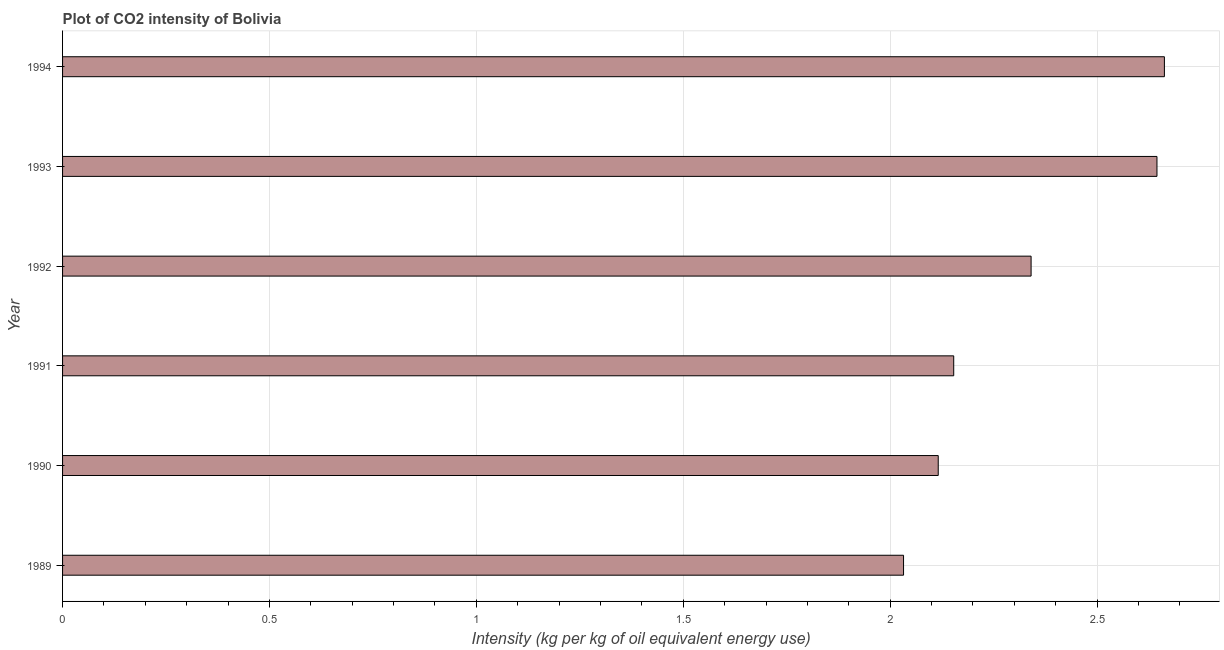Does the graph contain any zero values?
Ensure brevity in your answer.  No. Does the graph contain grids?
Provide a succinct answer. Yes. What is the title of the graph?
Offer a very short reply. Plot of CO2 intensity of Bolivia. What is the label or title of the X-axis?
Offer a terse response. Intensity (kg per kg of oil equivalent energy use). What is the co2 intensity in 1990?
Your answer should be very brief. 2.12. Across all years, what is the maximum co2 intensity?
Provide a short and direct response. 2.66. Across all years, what is the minimum co2 intensity?
Your answer should be very brief. 2.03. In which year was the co2 intensity maximum?
Give a very brief answer. 1994. In which year was the co2 intensity minimum?
Your answer should be very brief. 1989. What is the sum of the co2 intensity?
Your answer should be very brief. 13.95. What is the difference between the co2 intensity in 1989 and 1992?
Offer a terse response. -0.31. What is the average co2 intensity per year?
Offer a terse response. 2.33. What is the median co2 intensity?
Provide a succinct answer. 2.25. What is the ratio of the co2 intensity in 1992 to that in 1993?
Provide a short and direct response. 0.89. Is the co2 intensity in 1991 less than that in 1994?
Provide a succinct answer. Yes. What is the difference between the highest and the second highest co2 intensity?
Offer a very short reply. 0.02. Is the sum of the co2 intensity in 1993 and 1994 greater than the maximum co2 intensity across all years?
Your answer should be very brief. Yes. What is the difference between the highest and the lowest co2 intensity?
Provide a short and direct response. 0.63. How many years are there in the graph?
Your response must be concise. 6. What is the difference between two consecutive major ticks on the X-axis?
Your response must be concise. 0.5. Are the values on the major ticks of X-axis written in scientific E-notation?
Provide a short and direct response. No. What is the Intensity (kg per kg of oil equivalent energy use) in 1989?
Make the answer very short. 2.03. What is the Intensity (kg per kg of oil equivalent energy use) of 1990?
Keep it short and to the point. 2.12. What is the Intensity (kg per kg of oil equivalent energy use) in 1991?
Give a very brief answer. 2.15. What is the Intensity (kg per kg of oil equivalent energy use) in 1992?
Provide a short and direct response. 2.34. What is the Intensity (kg per kg of oil equivalent energy use) of 1993?
Provide a short and direct response. 2.64. What is the Intensity (kg per kg of oil equivalent energy use) of 1994?
Provide a succinct answer. 2.66. What is the difference between the Intensity (kg per kg of oil equivalent energy use) in 1989 and 1990?
Provide a short and direct response. -0.08. What is the difference between the Intensity (kg per kg of oil equivalent energy use) in 1989 and 1991?
Provide a succinct answer. -0.12. What is the difference between the Intensity (kg per kg of oil equivalent energy use) in 1989 and 1992?
Make the answer very short. -0.31. What is the difference between the Intensity (kg per kg of oil equivalent energy use) in 1989 and 1993?
Ensure brevity in your answer.  -0.61. What is the difference between the Intensity (kg per kg of oil equivalent energy use) in 1989 and 1994?
Your response must be concise. -0.63. What is the difference between the Intensity (kg per kg of oil equivalent energy use) in 1990 and 1991?
Give a very brief answer. -0.04. What is the difference between the Intensity (kg per kg of oil equivalent energy use) in 1990 and 1992?
Your response must be concise. -0.22. What is the difference between the Intensity (kg per kg of oil equivalent energy use) in 1990 and 1993?
Offer a terse response. -0.53. What is the difference between the Intensity (kg per kg of oil equivalent energy use) in 1990 and 1994?
Ensure brevity in your answer.  -0.55. What is the difference between the Intensity (kg per kg of oil equivalent energy use) in 1991 and 1992?
Provide a succinct answer. -0.19. What is the difference between the Intensity (kg per kg of oil equivalent energy use) in 1991 and 1993?
Make the answer very short. -0.49. What is the difference between the Intensity (kg per kg of oil equivalent energy use) in 1991 and 1994?
Offer a very short reply. -0.51. What is the difference between the Intensity (kg per kg of oil equivalent energy use) in 1992 and 1993?
Keep it short and to the point. -0.3. What is the difference between the Intensity (kg per kg of oil equivalent energy use) in 1992 and 1994?
Ensure brevity in your answer.  -0.32. What is the difference between the Intensity (kg per kg of oil equivalent energy use) in 1993 and 1994?
Provide a short and direct response. -0.02. What is the ratio of the Intensity (kg per kg of oil equivalent energy use) in 1989 to that in 1991?
Offer a very short reply. 0.94. What is the ratio of the Intensity (kg per kg of oil equivalent energy use) in 1989 to that in 1992?
Your response must be concise. 0.87. What is the ratio of the Intensity (kg per kg of oil equivalent energy use) in 1989 to that in 1993?
Offer a terse response. 0.77. What is the ratio of the Intensity (kg per kg of oil equivalent energy use) in 1989 to that in 1994?
Give a very brief answer. 0.76. What is the ratio of the Intensity (kg per kg of oil equivalent energy use) in 1990 to that in 1992?
Give a very brief answer. 0.9. What is the ratio of the Intensity (kg per kg of oil equivalent energy use) in 1990 to that in 1994?
Your answer should be very brief. 0.8. What is the ratio of the Intensity (kg per kg of oil equivalent energy use) in 1991 to that in 1992?
Offer a very short reply. 0.92. What is the ratio of the Intensity (kg per kg of oil equivalent energy use) in 1991 to that in 1993?
Give a very brief answer. 0.81. What is the ratio of the Intensity (kg per kg of oil equivalent energy use) in 1991 to that in 1994?
Your answer should be very brief. 0.81. What is the ratio of the Intensity (kg per kg of oil equivalent energy use) in 1992 to that in 1993?
Provide a short and direct response. 0.89. What is the ratio of the Intensity (kg per kg of oil equivalent energy use) in 1992 to that in 1994?
Your response must be concise. 0.88. What is the ratio of the Intensity (kg per kg of oil equivalent energy use) in 1993 to that in 1994?
Ensure brevity in your answer.  0.99. 